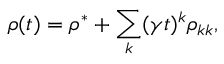<formula> <loc_0><loc_0><loc_500><loc_500>\rho ( t ) = \rho ^ { * } + \sum _ { k } ( \gamma t ) ^ { k } \rho _ { k k } ,</formula> 